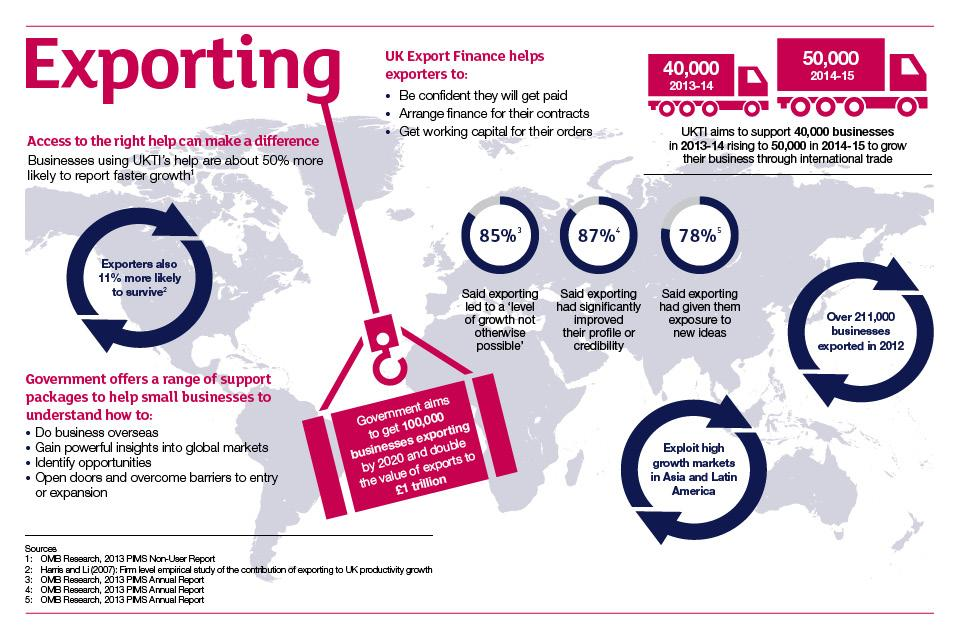Specify some key components in this picture. The number of businesses increased by approximately 10,000 from 2013-14 to 2014-15. 